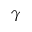<formula> <loc_0><loc_0><loc_500><loc_500>\gamma</formula> 